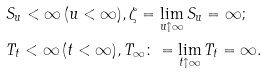Convert formula to latex. <formula><loc_0><loc_0><loc_500><loc_500>& S _ { u } < \infty \, ( u < \infty ) , \zeta = \lim _ { u \uparrow \infty } S _ { u } = \infty ; \\ & T _ { t } < \infty \, ( t < \infty ) , T _ { \infty } \colon = \lim _ { t \uparrow \infty } T _ { t } = \infty .</formula> 